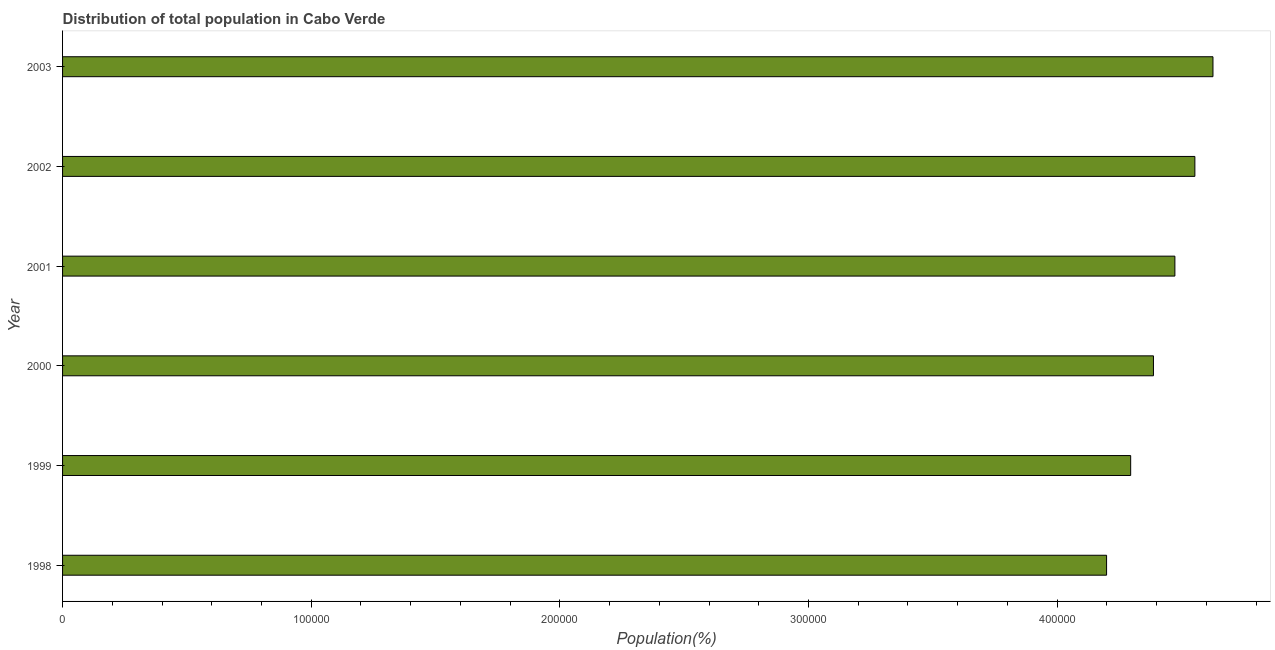Does the graph contain any zero values?
Make the answer very short. No. What is the title of the graph?
Your answer should be compact. Distribution of total population in Cabo Verde . What is the label or title of the X-axis?
Make the answer very short. Population(%). What is the label or title of the Y-axis?
Your response must be concise. Year. What is the population in 2000?
Give a very brief answer. 4.39e+05. Across all years, what is the maximum population?
Your response must be concise. 4.63e+05. Across all years, what is the minimum population?
Make the answer very short. 4.20e+05. In which year was the population minimum?
Make the answer very short. 1998. What is the sum of the population?
Make the answer very short. 2.65e+06. What is the difference between the population in 1998 and 2001?
Make the answer very short. -2.75e+04. What is the average population per year?
Keep it short and to the point. 4.42e+05. What is the median population?
Offer a very short reply. 4.43e+05. In how many years, is the population greater than 100000 %?
Keep it short and to the point. 6. Do a majority of the years between 1999 and 1998 (inclusive) have population greater than 160000 %?
Ensure brevity in your answer.  No. What is the ratio of the population in 1999 to that in 2003?
Make the answer very short. 0.93. What is the difference between the highest and the second highest population?
Give a very brief answer. 7279. What is the difference between the highest and the lowest population?
Offer a very short reply. 4.28e+04. In how many years, is the population greater than the average population taken over all years?
Offer a very short reply. 3. How many bars are there?
Offer a terse response. 6. Are all the bars in the graph horizontal?
Provide a short and direct response. Yes. What is the difference between two consecutive major ticks on the X-axis?
Provide a short and direct response. 1.00e+05. What is the Population(%) of 1998?
Make the answer very short. 4.20e+05. What is the Population(%) in 1999?
Offer a very short reply. 4.30e+05. What is the Population(%) of 2000?
Keep it short and to the point. 4.39e+05. What is the Population(%) of 2001?
Offer a very short reply. 4.47e+05. What is the Population(%) of 2002?
Your answer should be compact. 4.55e+05. What is the Population(%) in 2003?
Make the answer very short. 4.63e+05. What is the difference between the Population(%) in 1998 and 1999?
Provide a short and direct response. -9692. What is the difference between the Population(%) in 1998 and 2000?
Give a very brief answer. -1.89e+04. What is the difference between the Population(%) in 1998 and 2001?
Make the answer very short. -2.75e+04. What is the difference between the Population(%) in 1998 and 2002?
Give a very brief answer. -3.55e+04. What is the difference between the Population(%) in 1998 and 2003?
Offer a very short reply. -4.28e+04. What is the difference between the Population(%) in 1999 and 2000?
Provide a succinct answer. -9161. What is the difference between the Population(%) in 1999 and 2001?
Give a very brief answer. -1.78e+04. What is the difference between the Population(%) in 1999 and 2002?
Ensure brevity in your answer.  -2.58e+04. What is the difference between the Population(%) in 1999 and 2003?
Offer a very short reply. -3.31e+04. What is the difference between the Population(%) in 2000 and 2001?
Your answer should be compact. -8620. What is the difference between the Population(%) in 2000 and 2002?
Your response must be concise. -1.67e+04. What is the difference between the Population(%) in 2000 and 2003?
Your response must be concise. -2.39e+04. What is the difference between the Population(%) in 2001 and 2002?
Your answer should be very brief. -8039. What is the difference between the Population(%) in 2001 and 2003?
Provide a succinct answer. -1.53e+04. What is the difference between the Population(%) in 2002 and 2003?
Offer a terse response. -7279. What is the ratio of the Population(%) in 1998 to that in 2001?
Provide a short and direct response. 0.94. What is the ratio of the Population(%) in 1998 to that in 2002?
Your response must be concise. 0.92. What is the ratio of the Population(%) in 1998 to that in 2003?
Keep it short and to the point. 0.91. What is the ratio of the Population(%) in 1999 to that in 2001?
Give a very brief answer. 0.96. What is the ratio of the Population(%) in 1999 to that in 2002?
Make the answer very short. 0.94. What is the ratio of the Population(%) in 1999 to that in 2003?
Your answer should be compact. 0.93. What is the ratio of the Population(%) in 2000 to that in 2002?
Your response must be concise. 0.96. What is the ratio of the Population(%) in 2000 to that in 2003?
Offer a very short reply. 0.95. What is the ratio of the Population(%) in 2001 to that in 2003?
Your response must be concise. 0.97. What is the ratio of the Population(%) in 2002 to that in 2003?
Your answer should be very brief. 0.98. 